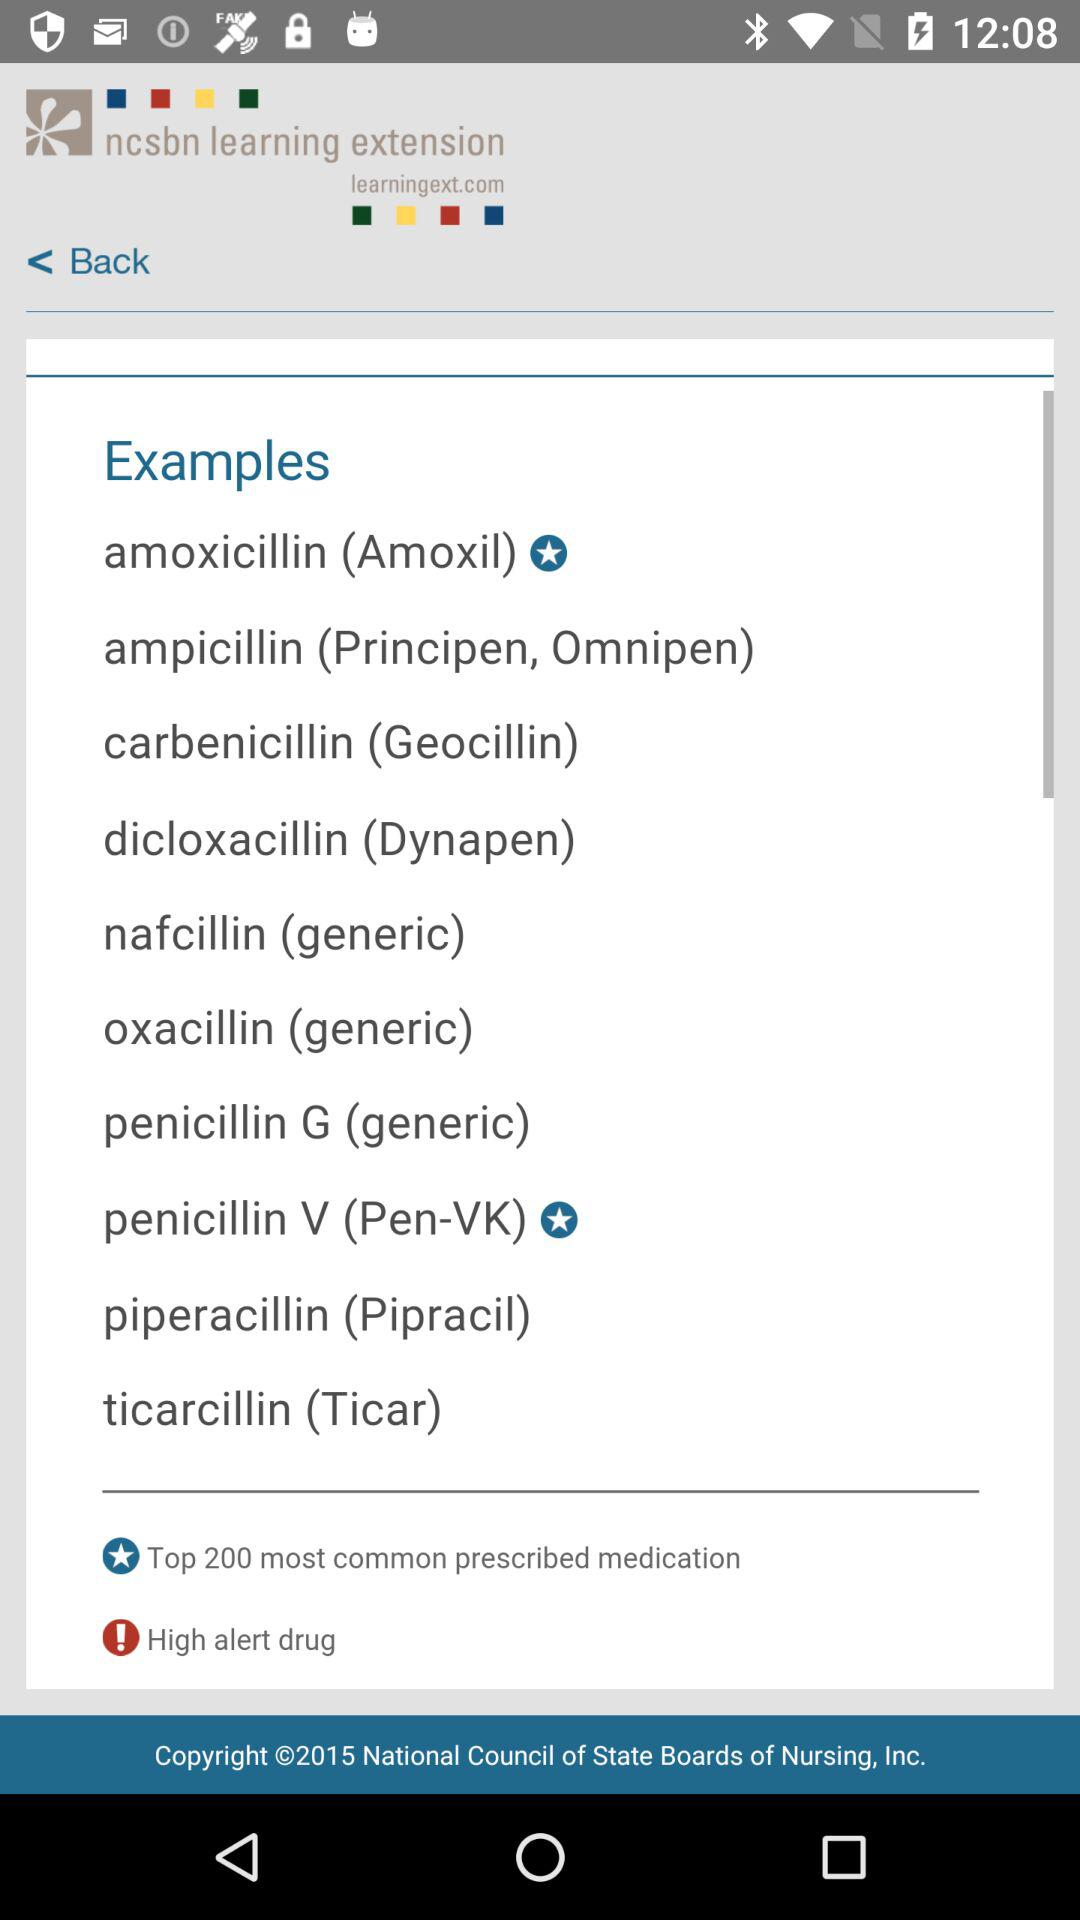What is the application name? The application name is "ncsbn learning extension". 